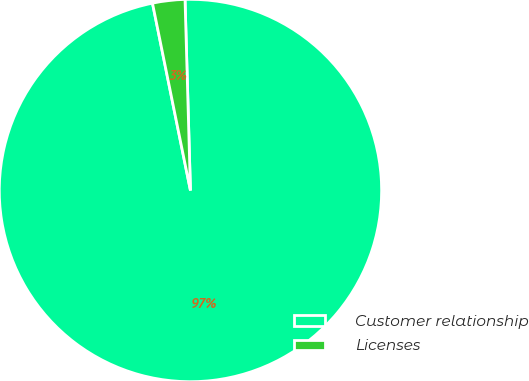Convert chart to OTSL. <chart><loc_0><loc_0><loc_500><loc_500><pie_chart><fcel>Customer relationship<fcel>Licenses<nl><fcel>97.27%<fcel>2.73%<nl></chart> 